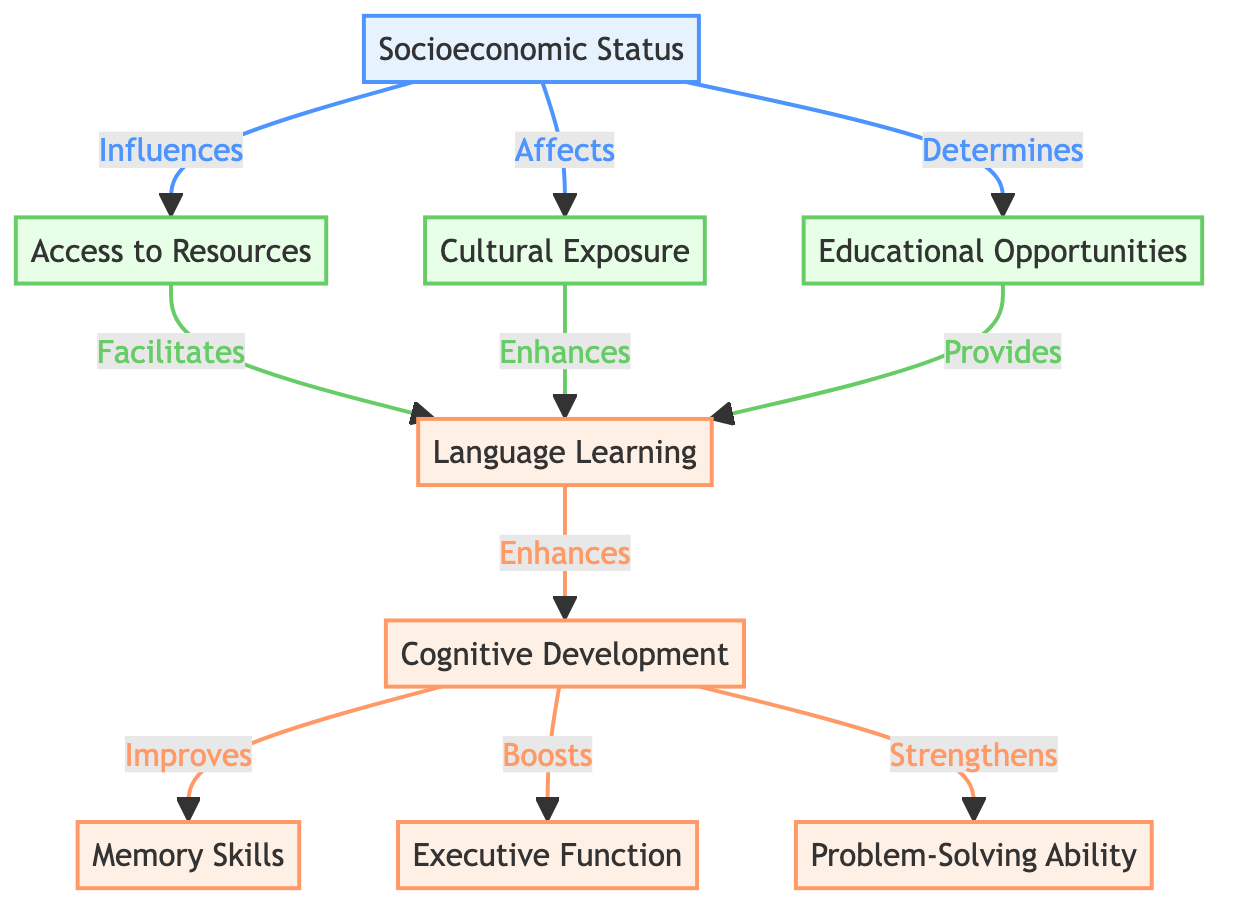What is the main topic of the diagram? The diagram centers around the relationship between language learning and cognitive development from a socioeconomic perspective, showing how these elements interact with one another.
Answer: The Impact of Language Learning on Cognitive Development How many cognitive development aspects are listed in the diagram? The diagram identifies three specific aspects of cognitive development, which are memory skills, executive function, and problem-solving ability.
Answer: Three Which node directly influences access to resources? The socioeconomic status node is shown to directly influence access to resources in the diagram, indicating that an individual's financial standing can affect their ability to access language learning materials and opportunities.
Answer: Socioeconomic Status What does memory skills improve from? Memory skills improve from cognitive development, as illustrated by the arrow connecting cognitive development to memory skills, indicating that enhanced cognitive development leads to better memory skills.
Answer: Cognitive Development How many nodes represent resources in the diagram? The diagram contains three nodes that represent resources: access to resources, cultural exposure, and educational opportunities. This highlights the different forms of support that can enhance language learning.
Answer: Three How does access to resources affect language learning? Access to resources facilitates language learning, as shown by the directed arrow connecting access to resources back to language learning, indicating that more resources lead to better language acquisition.
Answer: Facilitates Which two aspects of cognitive development are directly improved by language learning? Language learning directly improves memory skills and executive function, as indicated by the arrows leading from language learning to these two cognitive aspects in the diagram.
Answer: Memory Skills and Executive Function Which node determines educational opportunities? The socioeconomic status node determines educational opportunities, highlighting how the economic factors influence the quality and availability of education in language learning.
Answer: Socioeconomic Status What enhances language learning according to the diagram? Both cultural exposure and educational opportunities enhance language learning, as indicated by their respective connections to the language learning node, suggesting that these factors play a crucial role in the effectiveness of language acquisition.
Answer: Cultural Exposure and Educational Opportunities 